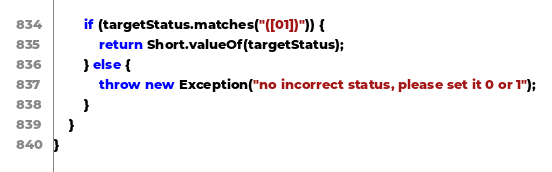<code> <loc_0><loc_0><loc_500><loc_500><_Java_>        if (targetStatus.matches("([01])")) {
            return Short.valueOf(targetStatus);
        } else {
            throw new Exception("no incorrect status, please set it 0 or 1");
        }
    }
}
</code> 